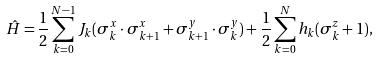<formula> <loc_0><loc_0><loc_500><loc_500>\hat { H } = \frac { 1 } { 2 } \sum _ { k = 0 } ^ { N - 1 } J _ { k } ( \sigma ^ { x } _ { k } \cdot \sigma ^ { x } _ { k + 1 } + \sigma ^ { y } _ { k + 1 } \cdot \sigma ^ { y } _ { k } ) + \frac { 1 } { 2 } \sum _ { k = 0 } ^ { N } h _ { k } ( \sigma ^ { z } _ { k } + 1 ) ,</formula> 